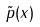Convert formula to latex. <formula><loc_0><loc_0><loc_500><loc_500>\tilde { p } ( x )</formula> 